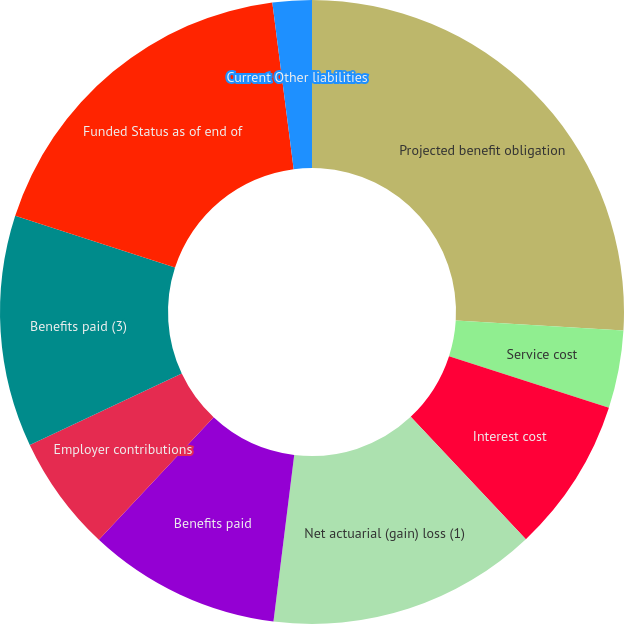<chart> <loc_0><loc_0><loc_500><loc_500><pie_chart><fcel>Projected benefit obligation<fcel>Service cost<fcel>Interest cost<fcel>Net actuarial (gain) loss (1)<fcel>Benefits paid<fcel>Employer contributions<fcel>Benefits paid (3)<fcel>Funded Status as of end of<fcel>Current Other liabilities<nl><fcel>25.95%<fcel>4.02%<fcel>8.01%<fcel>13.99%<fcel>10.0%<fcel>6.02%<fcel>12.0%<fcel>17.98%<fcel>2.03%<nl></chart> 